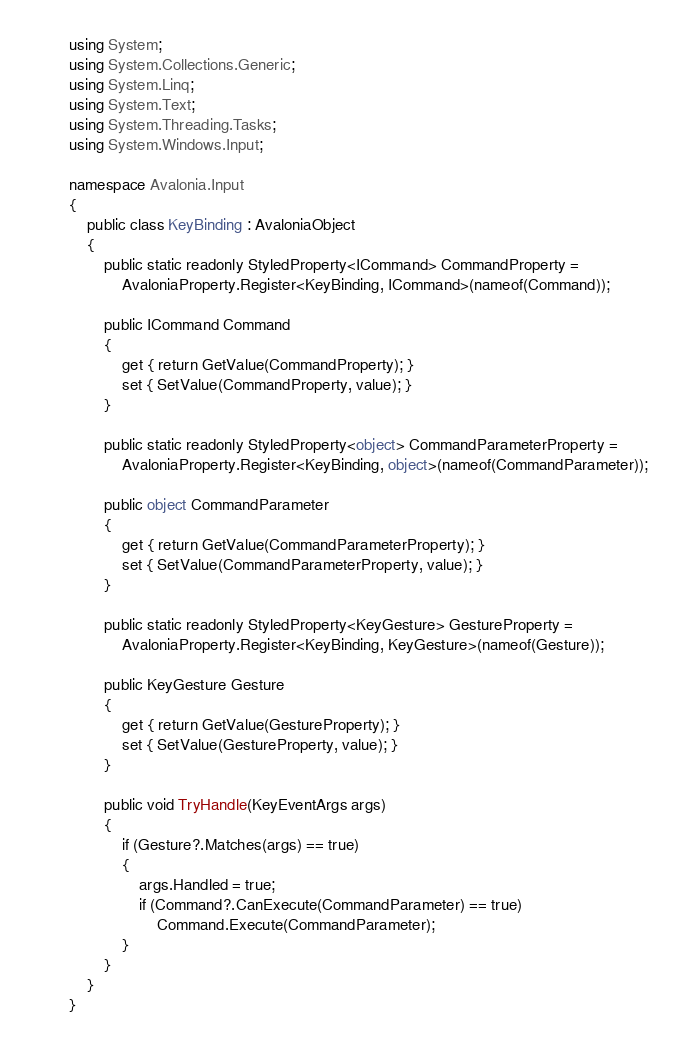Convert code to text. <code><loc_0><loc_0><loc_500><loc_500><_C#_>using System;
using System.Collections.Generic;
using System.Linq;
using System.Text;
using System.Threading.Tasks;
using System.Windows.Input;

namespace Avalonia.Input
{
    public class KeyBinding : AvaloniaObject
    {
        public static readonly StyledProperty<ICommand> CommandProperty =
            AvaloniaProperty.Register<KeyBinding, ICommand>(nameof(Command));

        public ICommand Command
        {
            get { return GetValue(CommandProperty); }
            set { SetValue(CommandProperty, value); }
        }

        public static readonly StyledProperty<object> CommandParameterProperty =
            AvaloniaProperty.Register<KeyBinding, object>(nameof(CommandParameter));

        public object CommandParameter
        {
            get { return GetValue(CommandParameterProperty); }
            set { SetValue(CommandParameterProperty, value); }
        }

        public static readonly StyledProperty<KeyGesture> GestureProperty =
            AvaloniaProperty.Register<KeyBinding, KeyGesture>(nameof(Gesture));

        public KeyGesture Gesture
        {
            get { return GetValue(GestureProperty); }
            set { SetValue(GestureProperty, value); }
        }

        public void TryHandle(KeyEventArgs args)
        {
            if (Gesture?.Matches(args) == true)
            {
                args.Handled = true;
                if (Command?.CanExecute(CommandParameter) == true)
                    Command.Execute(CommandParameter);
            }
        }
    }
}
</code> 